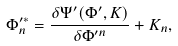Convert formula to latex. <formula><loc_0><loc_0><loc_500><loc_500>\Phi _ { n } ^ { \prime * } = \frac { \delta \Psi ^ { \prime } ( \Phi ^ { \prime } , K ) } { \delta \Phi ^ { \prime n } } + K _ { n } ,</formula> 